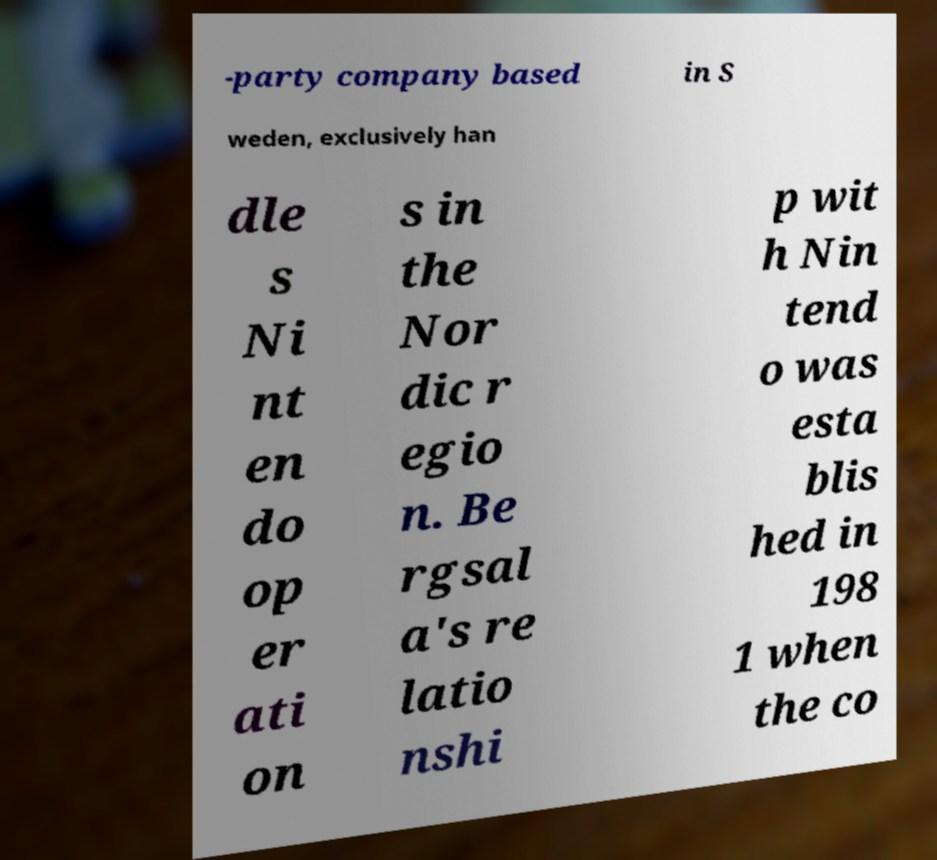Please identify and transcribe the text found in this image. -party company based in S weden, exclusively han dle s Ni nt en do op er ati on s in the Nor dic r egio n. Be rgsal a's re latio nshi p wit h Nin tend o was esta blis hed in 198 1 when the co 